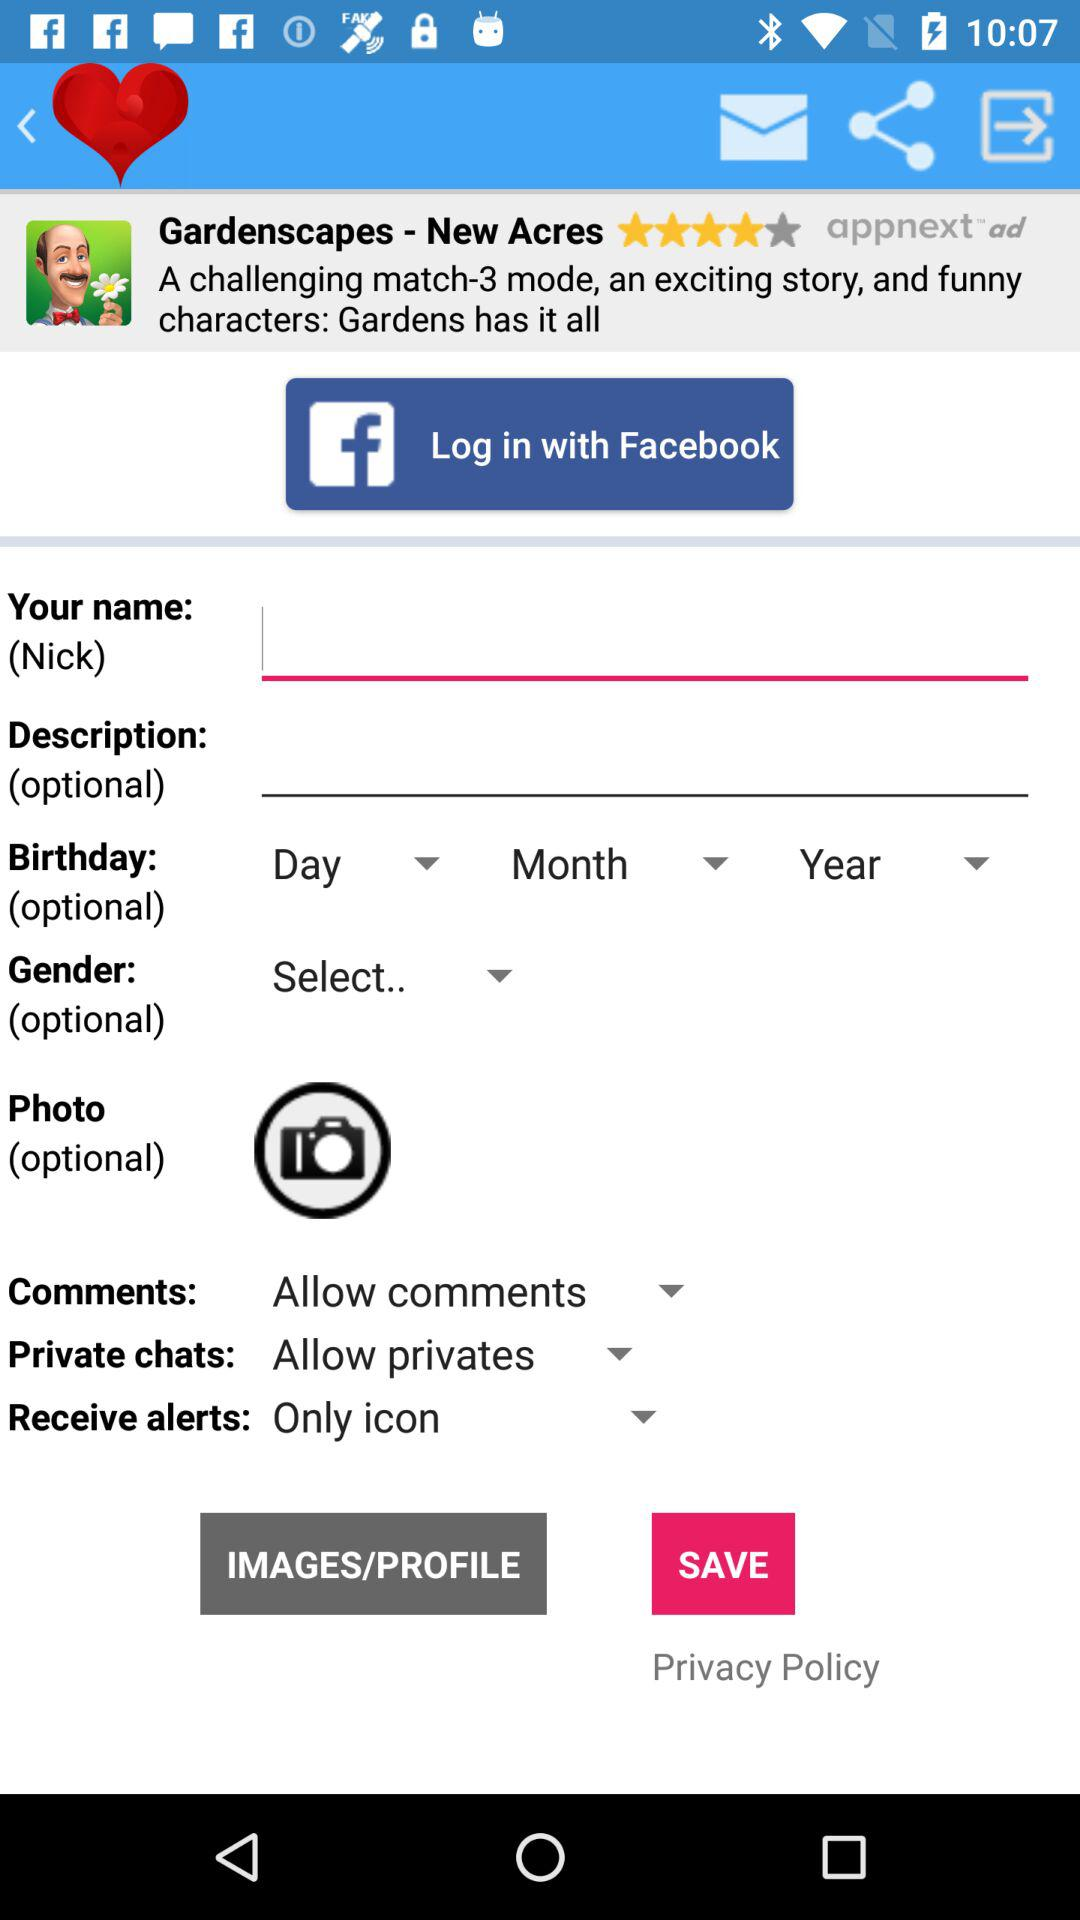What is the rating of "Gardenscapes - New Acres"? The rating is 4 stars. 